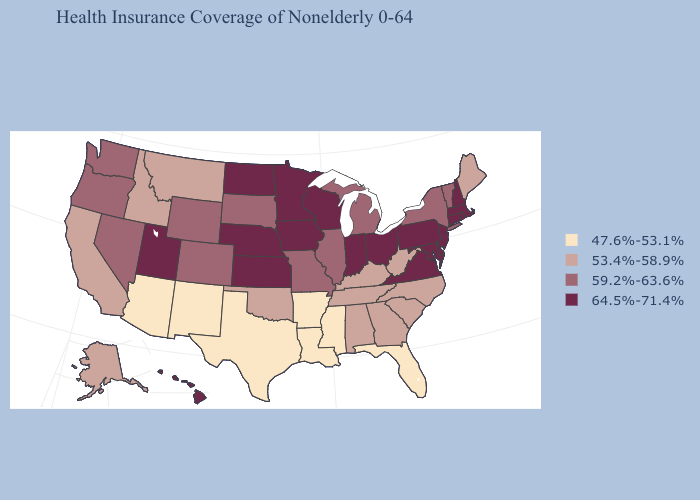How many symbols are there in the legend?
Keep it brief. 4. Among the states that border Wyoming , which have the highest value?
Write a very short answer. Nebraska, Utah. Does California have a higher value than Idaho?
Short answer required. No. Name the states that have a value in the range 64.5%-71.4%?
Keep it brief. Connecticut, Delaware, Hawaii, Indiana, Iowa, Kansas, Maryland, Massachusetts, Minnesota, Nebraska, New Hampshire, New Jersey, North Dakota, Ohio, Pennsylvania, Rhode Island, Utah, Virginia, Wisconsin. Does the first symbol in the legend represent the smallest category?
Concise answer only. Yes. What is the highest value in states that border Vermont?
Concise answer only. 64.5%-71.4%. What is the lowest value in the South?
Answer briefly. 47.6%-53.1%. Name the states that have a value in the range 59.2%-63.6%?
Write a very short answer. Colorado, Illinois, Michigan, Missouri, Nevada, New York, Oregon, South Dakota, Vermont, Washington, Wyoming. What is the highest value in the South ?
Write a very short answer. 64.5%-71.4%. What is the value of Georgia?
Short answer required. 53.4%-58.9%. What is the value of Utah?
Be succinct. 64.5%-71.4%. Which states hav the highest value in the Northeast?
Write a very short answer. Connecticut, Massachusetts, New Hampshire, New Jersey, Pennsylvania, Rhode Island. Which states have the highest value in the USA?
Write a very short answer. Connecticut, Delaware, Hawaii, Indiana, Iowa, Kansas, Maryland, Massachusetts, Minnesota, Nebraska, New Hampshire, New Jersey, North Dakota, Ohio, Pennsylvania, Rhode Island, Utah, Virginia, Wisconsin. What is the lowest value in the USA?
Answer briefly. 47.6%-53.1%. What is the value of New York?
Quick response, please. 59.2%-63.6%. 